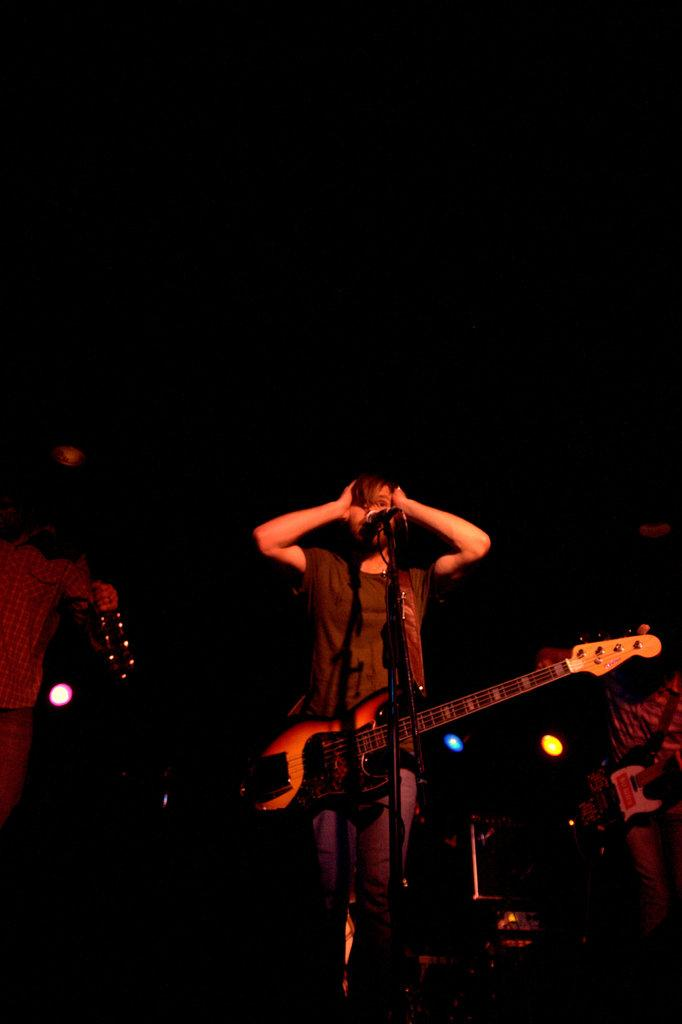What is the main subject of the image? There is a person standing in the center of the image. What object is visible near the person? There is a guitar in the image. What equipment is present for amplifying sound? There is a microphone on a stand in the image. Can you describe the people in the background of the image? There are people in the background of the image. What type of van can be seen in the background of the image? There is no van present in the image; it only features a person, a guitar, a microphone, and people in the background. 